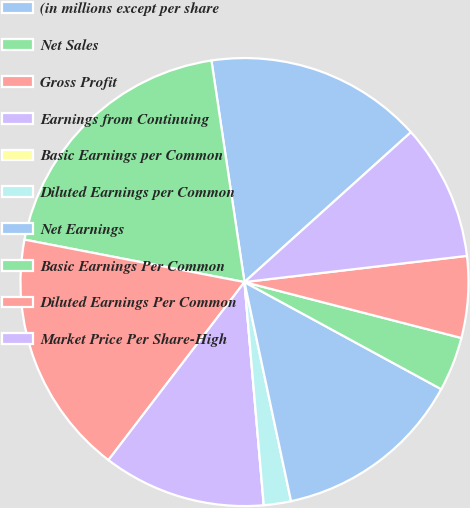<chart> <loc_0><loc_0><loc_500><loc_500><pie_chart><fcel>(in millions except per share<fcel>Net Sales<fcel>Gross Profit<fcel>Earnings from Continuing<fcel>Basic Earnings per Common<fcel>Diluted Earnings per Common<fcel>Net Earnings<fcel>Basic Earnings Per Common<fcel>Diluted Earnings Per Common<fcel>Market Price Per Share-High<nl><fcel>15.69%<fcel>19.61%<fcel>17.65%<fcel>11.76%<fcel>0.0%<fcel>1.96%<fcel>13.73%<fcel>3.92%<fcel>5.88%<fcel>9.8%<nl></chart> 